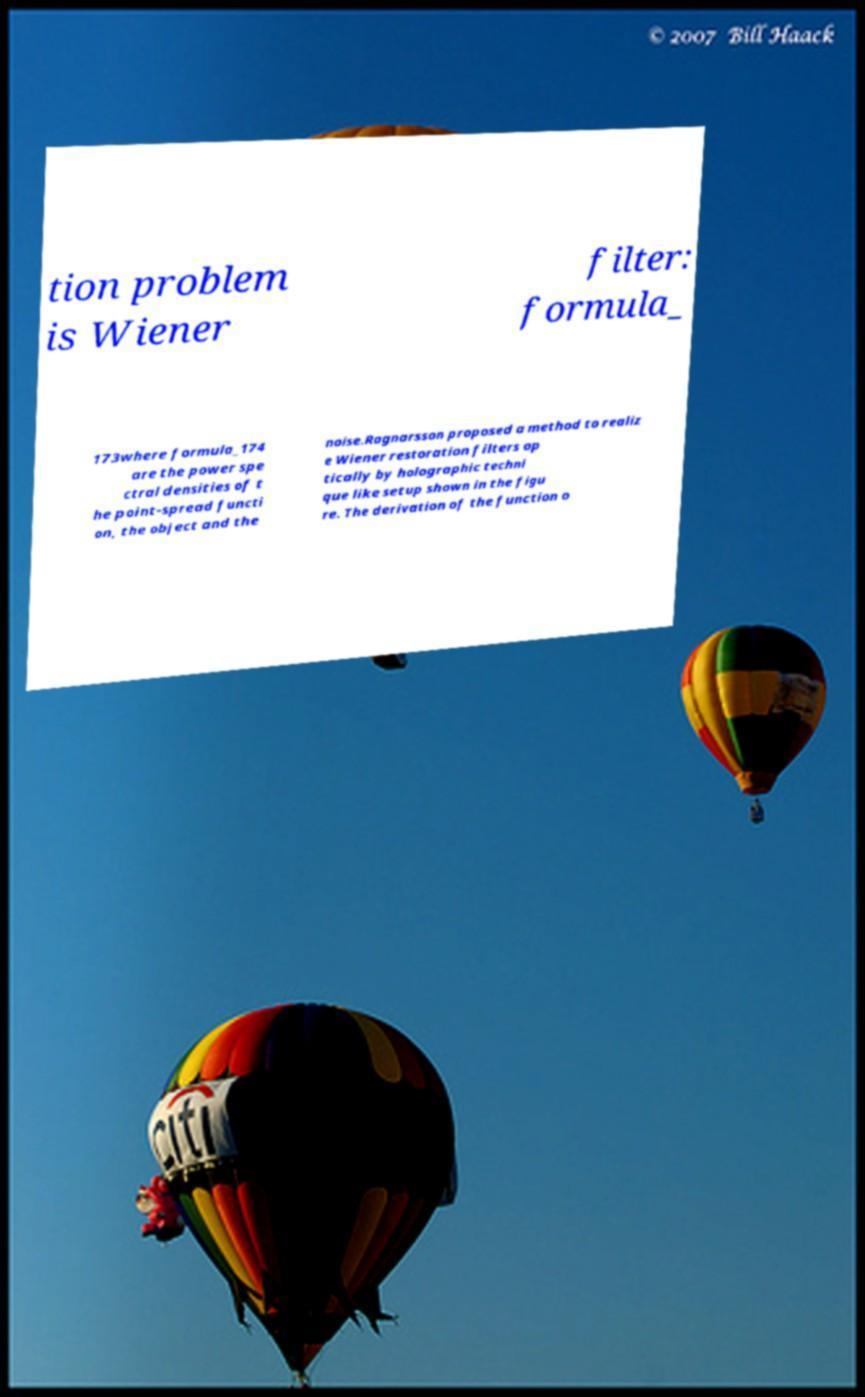Please read and relay the text visible in this image. What does it say? tion problem is Wiener filter: formula_ 173where formula_174 are the power spe ctral densities of t he point-spread functi on, the object and the noise.Ragnarsson proposed a method to realiz e Wiener restoration filters op tically by holographic techni que like setup shown in the figu re. The derivation of the function o 